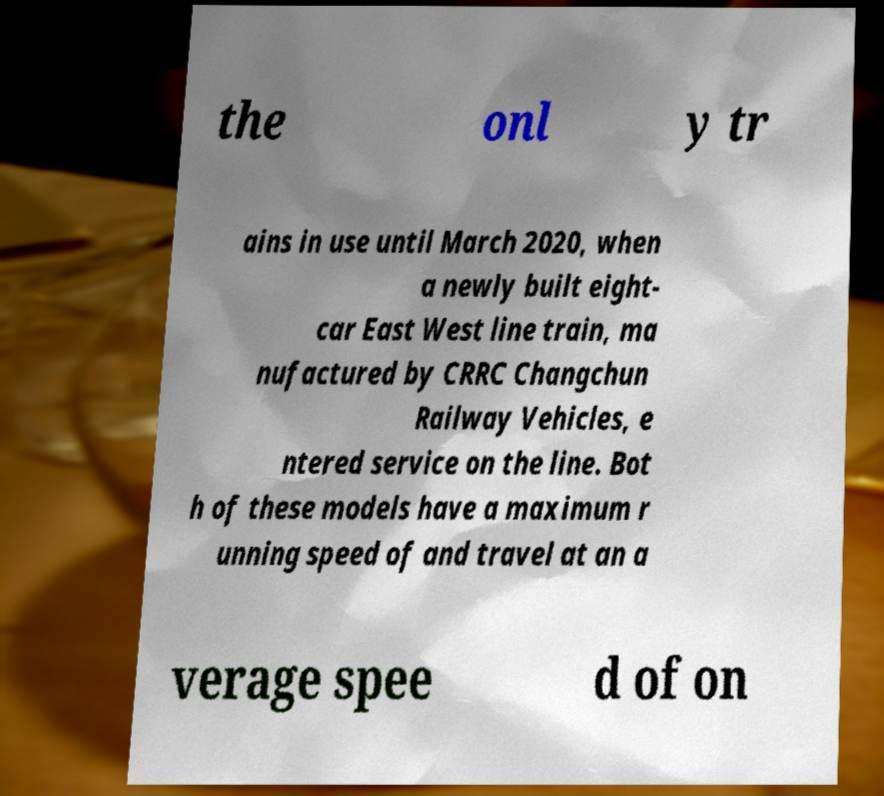Could you extract and type out the text from this image? the onl y tr ains in use until March 2020, when a newly built eight- car East West line train, ma nufactured by CRRC Changchun Railway Vehicles, e ntered service on the line. Bot h of these models have a maximum r unning speed of and travel at an a verage spee d of on 